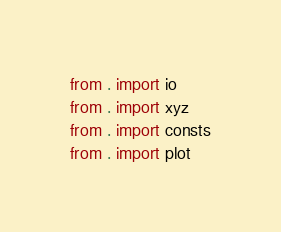<code> <loc_0><loc_0><loc_500><loc_500><_Python_>from . import io
from . import xyz
from . import consts
from . import plot</code> 